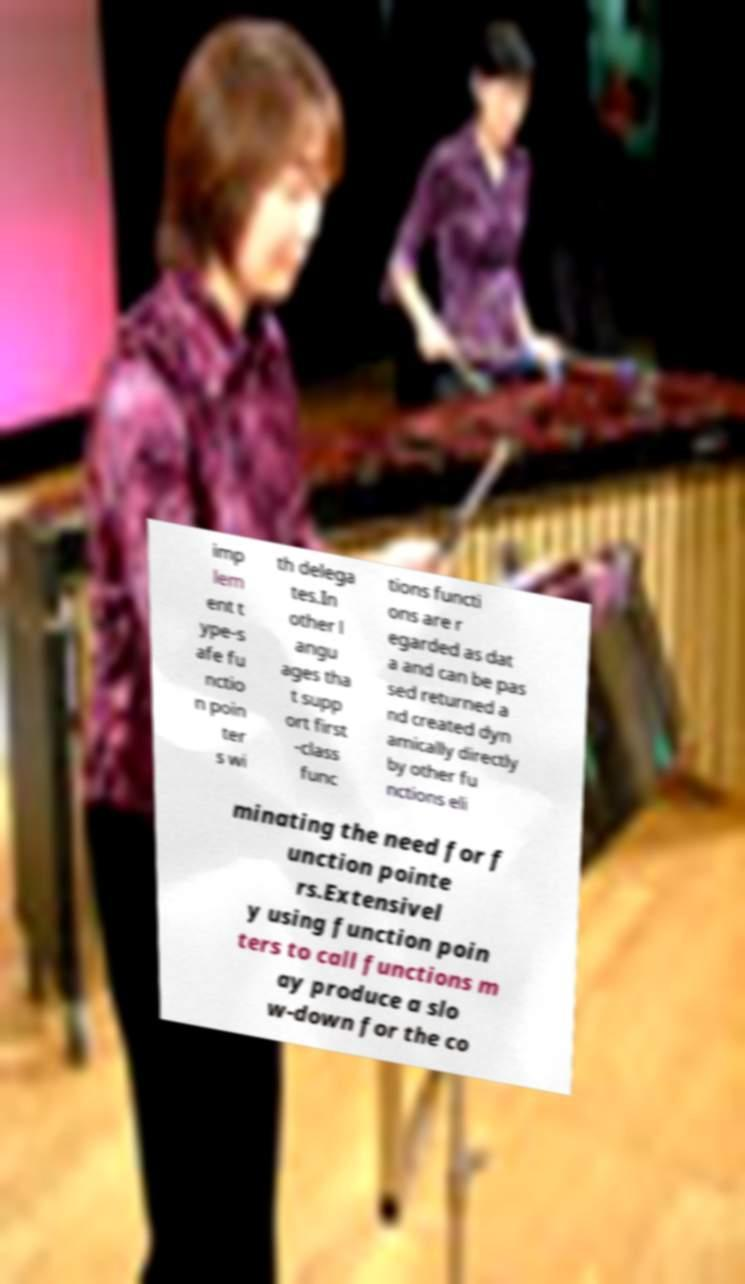Please identify and transcribe the text found in this image. imp lem ent t ype-s afe fu nctio n poin ter s wi th delega tes.In other l angu ages tha t supp ort first -class func tions functi ons are r egarded as dat a and can be pas sed returned a nd created dyn amically directly by other fu nctions eli minating the need for f unction pointe rs.Extensivel y using function poin ters to call functions m ay produce a slo w-down for the co 